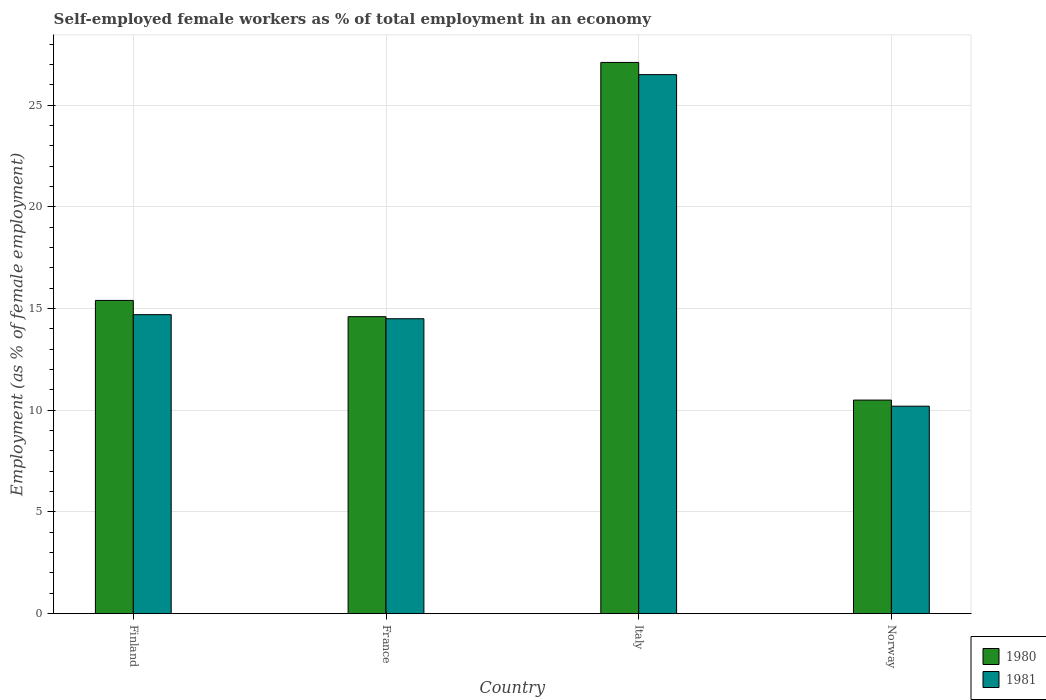How many different coloured bars are there?
Offer a very short reply. 2. How many groups of bars are there?
Your response must be concise. 4. Are the number of bars on each tick of the X-axis equal?
Offer a terse response. Yes. How many bars are there on the 1st tick from the right?
Ensure brevity in your answer.  2. What is the percentage of self-employed female workers in 1981 in Italy?
Your answer should be very brief. 26.5. What is the total percentage of self-employed female workers in 1981 in the graph?
Keep it short and to the point. 65.9. What is the difference between the percentage of self-employed female workers in 1980 in Finland and that in Norway?
Make the answer very short. 4.9. What is the difference between the percentage of self-employed female workers in 1981 in France and the percentage of self-employed female workers in 1980 in Italy?
Provide a short and direct response. -12.6. What is the average percentage of self-employed female workers in 1981 per country?
Your response must be concise. 16.47. What is the difference between the percentage of self-employed female workers of/in 1981 and percentage of self-employed female workers of/in 1980 in France?
Your response must be concise. -0.1. In how many countries, is the percentage of self-employed female workers in 1980 greater than 22 %?
Keep it short and to the point. 1. What is the ratio of the percentage of self-employed female workers in 1981 in Finland to that in Norway?
Ensure brevity in your answer.  1.44. Is the percentage of self-employed female workers in 1980 in Finland less than that in France?
Give a very brief answer. No. Is the difference between the percentage of self-employed female workers in 1981 in France and Norway greater than the difference between the percentage of self-employed female workers in 1980 in France and Norway?
Your answer should be very brief. Yes. What is the difference between the highest and the second highest percentage of self-employed female workers in 1981?
Ensure brevity in your answer.  11.8. What is the difference between the highest and the lowest percentage of self-employed female workers in 1981?
Make the answer very short. 16.3. In how many countries, is the percentage of self-employed female workers in 1981 greater than the average percentage of self-employed female workers in 1981 taken over all countries?
Give a very brief answer. 1. Is the sum of the percentage of self-employed female workers in 1981 in Finland and Norway greater than the maximum percentage of self-employed female workers in 1980 across all countries?
Provide a succinct answer. No. What does the 1st bar from the left in France represents?
Your answer should be compact. 1980. What is the difference between two consecutive major ticks on the Y-axis?
Provide a short and direct response. 5. Does the graph contain any zero values?
Keep it short and to the point. No. Does the graph contain grids?
Your answer should be very brief. Yes. Where does the legend appear in the graph?
Offer a very short reply. Bottom right. How many legend labels are there?
Provide a short and direct response. 2. How are the legend labels stacked?
Your answer should be very brief. Vertical. What is the title of the graph?
Offer a terse response. Self-employed female workers as % of total employment in an economy. What is the label or title of the X-axis?
Keep it short and to the point. Country. What is the label or title of the Y-axis?
Offer a terse response. Employment (as % of female employment). What is the Employment (as % of female employment) of 1980 in Finland?
Keep it short and to the point. 15.4. What is the Employment (as % of female employment) of 1981 in Finland?
Offer a terse response. 14.7. What is the Employment (as % of female employment) of 1980 in France?
Keep it short and to the point. 14.6. What is the Employment (as % of female employment) of 1981 in France?
Make the answer very short. 14.5. What is the Employment (as % of female employment) of 1980 in Italy?
Keep it short and to the point. 27.1. What is the Employment (as % of female employment) of 1981 in Italy?
Make the answer very short. 26.5. What is the Employment (as % of female employment) of 1980 in Norway?
Provide a short and direct response. 10.5. What is the Employment (as % of female employment) of 1981 in Norway?
Offer a terse response. 10.2. Across all countries, what is the maximum Employment (as % of female employment) in 1980?
Offer a terse response. 27.1. Across all countries, what is the minimum Employment (as % of female employment) of 1980?
Ensure brevity in your answer.  10.5. Across all countries, what is the minimum Employment (as % of female employment) in 1981?
Keep it short and to the point. 10.2. What is the total Employment (as % of female employment) of 1980 in the graph?
Provide a short and direct response. 67.6. What is the total Employment (as % of female employment) in 1981 in the graph?
Keep it short and to the point. 65.9. What is the difference between the Employment (as % of female employment) in 1980 in Finland and that in France?
Offer a very short reply. 0.8. What is the difference between the Employment (as % of female employment) in 1981 in Finland and that in Italy?
Offer a terse response. -11.8. What is the difference between the Employment (as % of female employment) in 1980 in Finland and that in Norway?
Your response must be concise. 4.9. What is the difference between the Employment (as % of female employment) in 1980 in France and that in Norway?
Provide a short and direct response. 4.1. What is the difference between the Employment (as % of female employment) of 1980 in Italy and that in Norway?
Ensure brevity in your answer.  16.6. What is the difference between the Employment (as % of female employment) of 1981 in Italy and that in Norway?
Your answer should be compact. 16.3. What is the difference between the Employment (as % of female employment) of 1980 in Finland and the Employment (as % of female employment) of 1981 in France?
Provide a succinct answer. 0.9. What is the difference between the Employment (as % of female employment) in 1980 in Finland and the Employment (as % of female employment) in 1981 in Norway?
Make the answer very short. 5.2. What is the average Employment (as % of female employment) in 1980 per country?
Ensure brevity in your answer.  16.9. What is the average Employment (as % of female employment) in 1981 per country?
Provide a succinct answer. 16.48. What is the difference between the Employment (as % of female employment) in 1980 and Employment (as % of female employment) in 1981 in Finland?
Provide a succinct answer. 0.7. What is the difference between the Employment (as % of female employment) in 1980 and Employment (as % of female employment) in 1981 in Norway?
Your answer should be very brief. 0.3. What is the ratio of the Employment (as % of female employment) of 1980 in Finland to that in France?
Make the answer very short. 1.05. What is the ratio of the Employment (as % of female employment) in 1981 in Finland to that in France?
Make the answer very short. 1.01. What is the ratio of the Employment (as % of female employment) of 1980 in Finland to that in Italy?
Offer a very short reply. 0.57. What is the ratio of the Employment (as % of female employment) in 1981 in Finland to that in Italy?
Make the answer very short. 0.55. What is the ratio of the Employment (as % of female employment) in 1980 in Finland to that in Norway?
Your response must be concise. 1.47. What is the ratio of the Employment (as % of female employment) in 1981 in Finland to that in Norway?
Provide a succinct answer. 1.44. What is the ratio of the Employment (as % of female employment) in 1980 in France to that in Italy?
Make the answer very short. 0.54. What is the ratio of the Employment (as % of female employment) of 1981 in France to that in Italy?
Your answer should be very brief. 0.55. What is the ratio of the Employment (as % of female employment) in 1980 in France to that in Norway?
Offer a terse response. 1.39. What is the ratio of the Employment (as % of female employment) of 1981 in France to that in Norway?
Your answer should be compact. 1.42. What is the ratio of the Employment (as % of female employment) in 1980 in Italy to that in Norway?
Your answer should be compact. 2.58. What is the ratio of the Employment (as % of female employment) in 1981 in Italy to that in Norway?
Your answer should be very brief. 2.6. What is the difference between the highest and the second highest Employment (as % of female employment) of 1980?
Keep it short and to the point. 11.7. What is the difference between the highest and the second highest Employment (as % of female employment) of 1981?
Provide a short and direct response. 11.8. What is the difference between the highest and the lowest Employment (as % of female employment) in 1980?
Your answer should be compact. 16.6. 